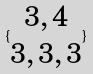Convert formula to latex. <formula><loc_0><loc_0><loc_500><loc_500>\{ \begin{matrix} 3 , 4 \\ 3 , 3 , 3 \end{matrix} \}</formula> 